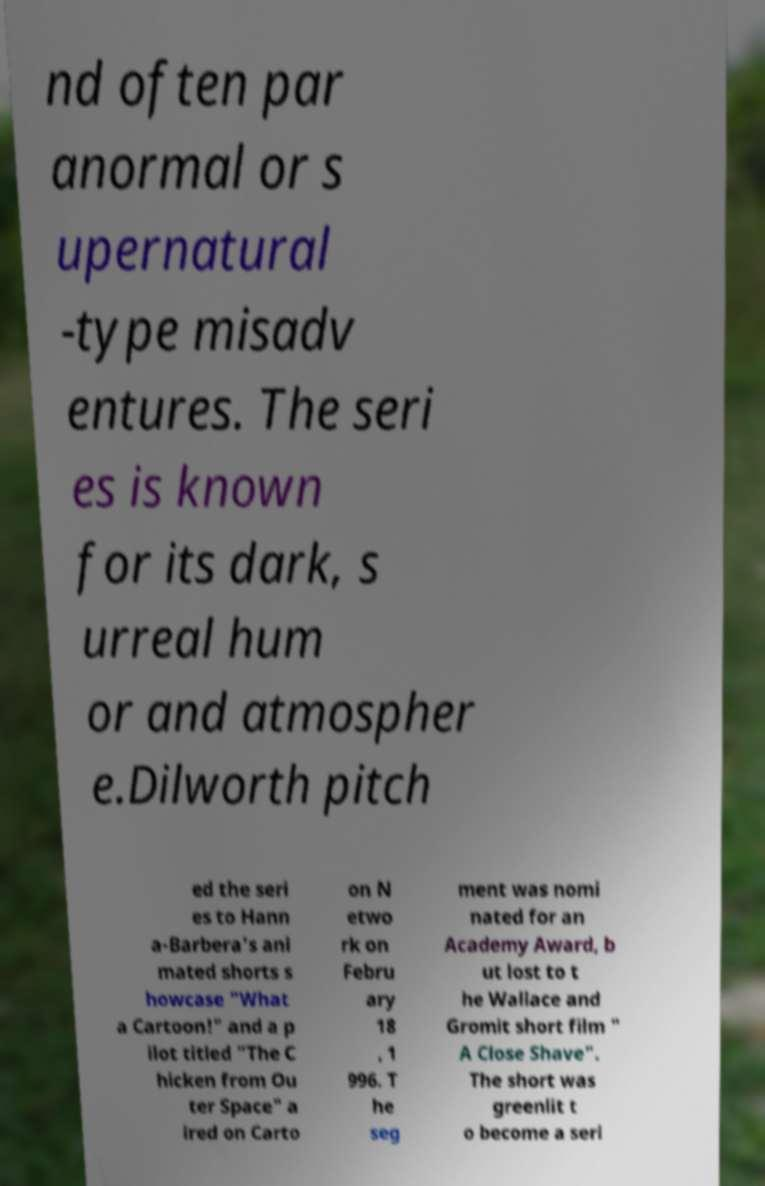Can you accurately transcribe the text from the provided image for me? nd often par anormal or s upernatural -type misadv entures. The seri es is known for its dark, s urreal hum or and atmospher e.Dilworth pitch ed the seri es to Hann a-Barbera's ani mated shorts s howcase "What a Cartoon!" and a p ilot titled "The C hicken from Ou ter Space" a ired on Carto on N etwo rk on Febru ary 18 , 1 996. T he seg ment was nomi nated for an Academy Award, b ut lost to t he Wallace and Gromit short film " A Close Shave". The short was greenlit t o become a seri 